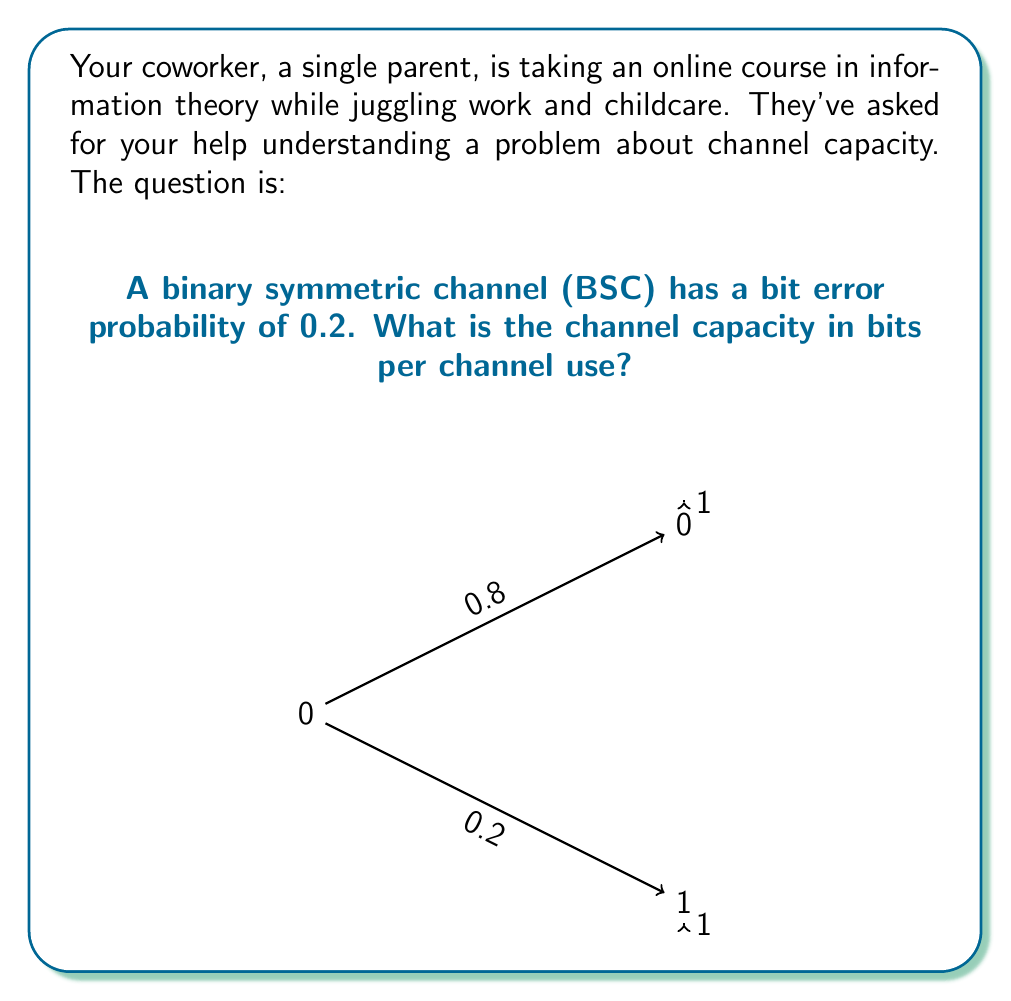What is the answer to this math problem? Let's approach this step-by-step:

1) The channel capacity (C) for a binary symmetric channel is given by:

   $$C = 1 - H(p)$$

   where $H(p)$ is the binary entropy function and $p$ is the bit error probability.

2) The binary entropy function is defined as:

   $$H(p) = -p \log_2(p) - (1-p) \log_2(1-p)$$

3) In this case, $p = 0.2$. Let's calculate $H(0.2)$:

   $$H(0.2) = -0.2 \log_2(0.2) - 0.8 \log_2(0.8)$$

4) Using a calculator or computer:

   $$H(0.2) \approx 0.7219$$

5) Now we can calculate the channel capacity:

   $$C = 1 - H(0.2) \approx 1 - 0.7219 \approx 0.2781$$

Therefore, the channel capacity is approximately 0.2781 bits per channel use.
Answer: 0.2781 bits per channel use 